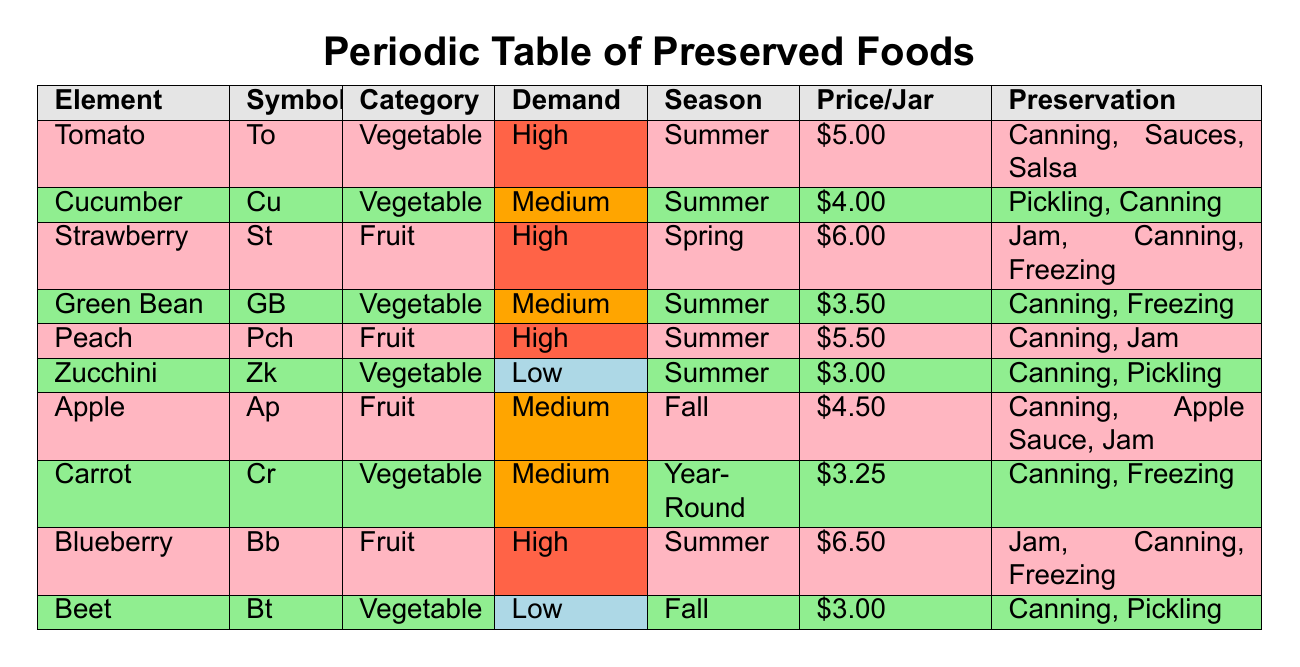What is the average price per jar of preserved foods? To find the average price per jar, we need to sum the average prices of all items and then divide by the number of items. The total price is 5.00 + 4.00 + 6.00 + 3.50 + 5.50 + 3.00 + 4.50 + 3.25 + 6.50 + 3.00 = 43.25. There are 10 items, so the average price is 43.25 / 10 = 4.325.
Answer: 4.33 Which fruit has the highest demand? By scanning the table, we can see that both Strawberry and Blueberry have a demand level categorized as High. However, since it asks for the highest, we could say Strawberry, as it is mentioned first in the table.
Answer: Strawberry Is there a vegetable that is available year-round? The table lists Carrot under seasonal availability as Year-Round, which indicates that it can be preserved at any time of the year.
Answer: Yes How many preservation methods are listed for Peach? The table shows that Peach can be preserved using two methods: Canning and Jam. The number of preservation methods is simply counted from the corresponding column.
Answer: 2 What is the difference in average price per jar between high demand and low demand categories? To find this, we calculate the average price for high and low demand separately. High demand prices: 5.00 (Tomato) + 6.00 (Strawberry) + 5.50 (Peach) + 6.50 (Blueberry) = 23.00, average is 23.00 / 4 = 5.75. Low demand prices: 3.00 (Zucchini) + 3.00 (Beet) = 6.00, average is 6.00 / 2 = 3.00. The difference is 5.75 - 3.00 = 2.75.
Answer: 2.75 How many fruits have a seasonal availability in Summer? We go through the table to identify fruits available in Summer. There are three: Strawberry, Peach, and Blueberry, which totals to three fruits.
Answer: 3 Is the average price of cucumbers lower than the average price of carrots? The average price of Cucumber is 4.00, and for Carrot, it is 3.25. Since 4.00 is greater than 3.25, the statement is false.
Answer: No What is the total number of preservation methods for all vegetables? We will summarize the preservation methods for each vegetable. Tomato has 3, Cucumber has 2, Green Bean has 2, Zucchini has 2, Carrot has 2, and Beet has 2, giving us a total of 3 + 2 + 2 + 2 + 2 + 2 = 13 methods.
Answer: 13 